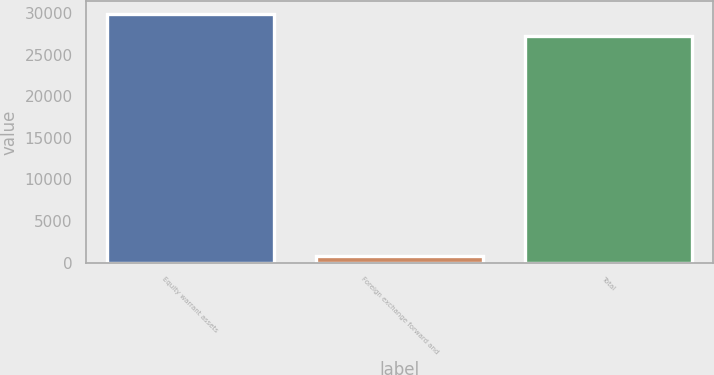Convert chart to OTSL. <chart><loc_0><loc_0><loc_500><loc_500><bar_chart><fcel>Equity warrant assets<fcel>Foreign exchange forward and<fcel>Total<nl><fcel>29957.6<fcel>766<fcel>27254<nl></chart> 